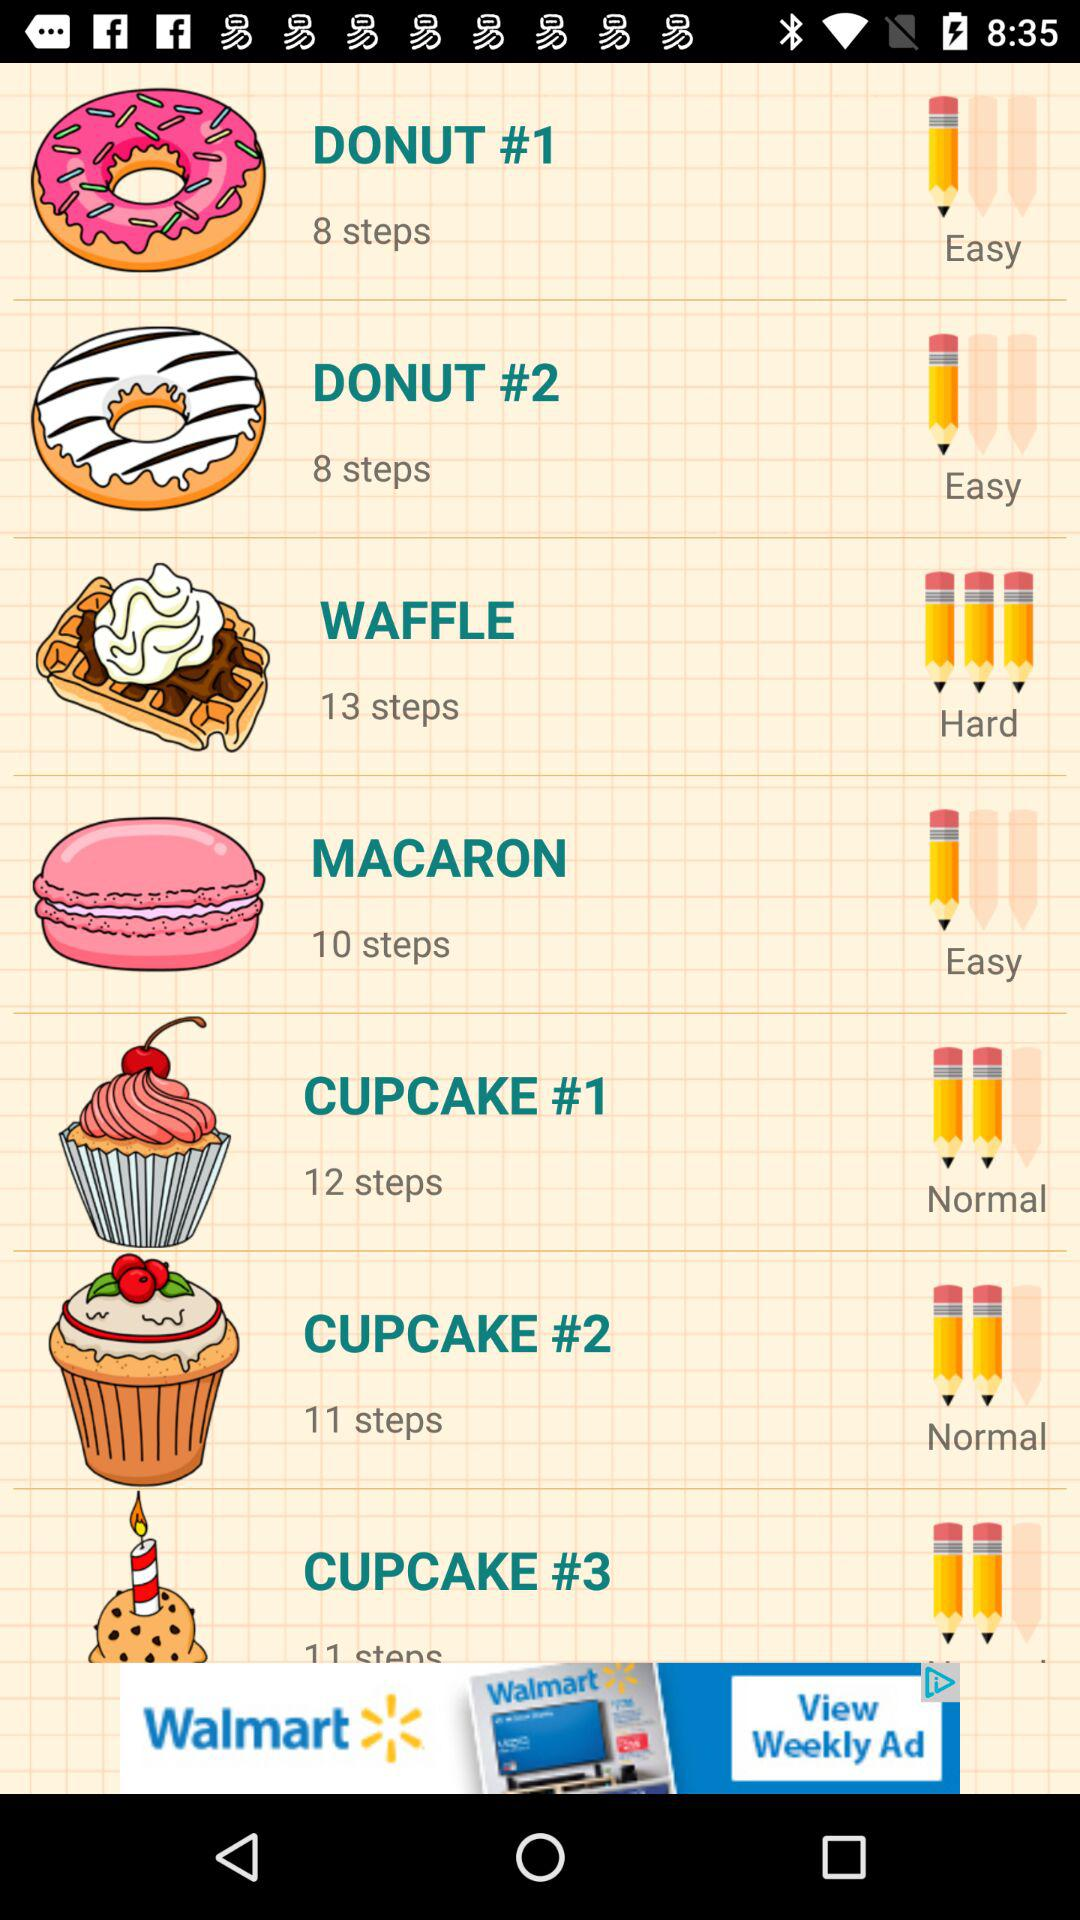What is the difficulty level of "MACARON"? The difficulty level is "Easy". 